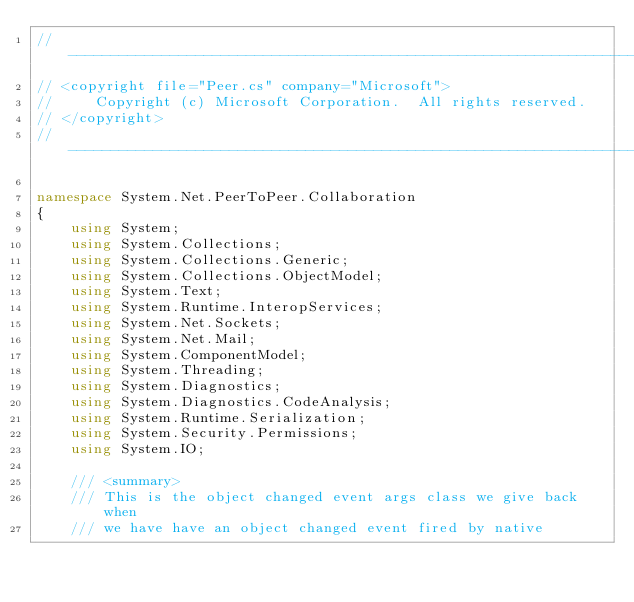<code> <loc_0><loc_0><loc_500><loc_500><_C#_>//------------------------------------------------------------------------------
// <copyright file="Peer.cs" company="Microsoft">
//     Copyright (c) Microsoft Corporation.  All rights reserved.
// </copyright>                                                                
//------------------------------------------------------------------------------

namespace System.Net.PeerToPeer.Collaboration
{
    using System;
    using System.Collections;
    using System.Collections.Generic;
    using System.Collections.ObjectModel;
    using System.Text;
    using System.Runtime.InteropServices;
    using System.Net.Sockets;
    using System.Net.Mail;
    using System.ComponentModel;
    using System.Threading;
    using System.Diagnostics;
    using System.Diagnostics.CodeAnalysis;
    using System.Runtime.Serialization;
    using System.Security.Permissions;
    using System.IO;

    /// <summary>
    /// This is the object changed event args class we give back when 
    /// we have have an object changed event fired by native</code> 